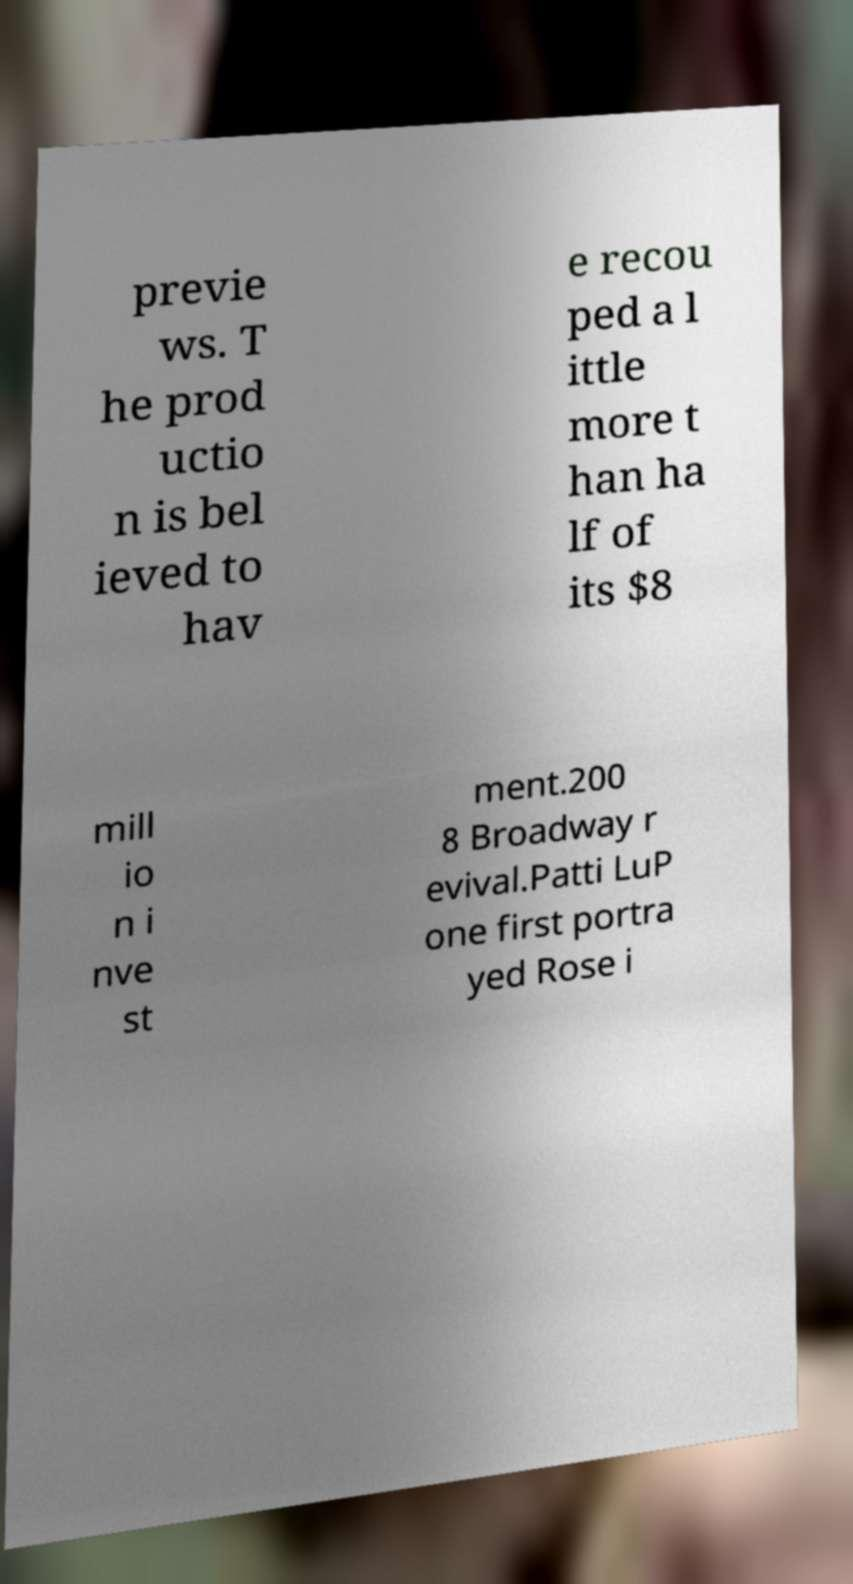Please read and relay the text visible in this image. What does it say? previe ws. T he prod uctio n is bel ieved to hav e recou ped a l ittle more t han ha lf of its $8 mill io n i nve st ment.200 8 Broadway r evival.Patti LuP one first portra yed Rose i 